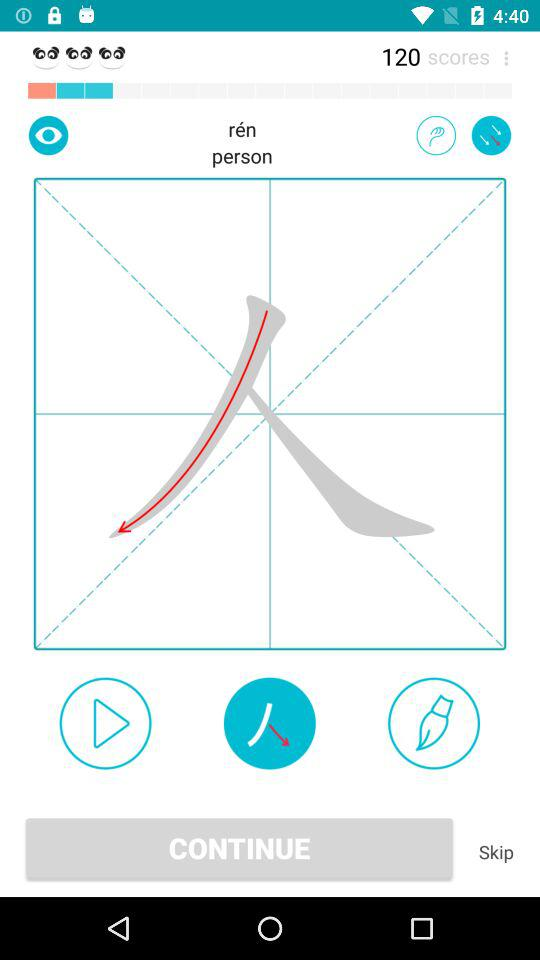What is the score? The score is 120. 